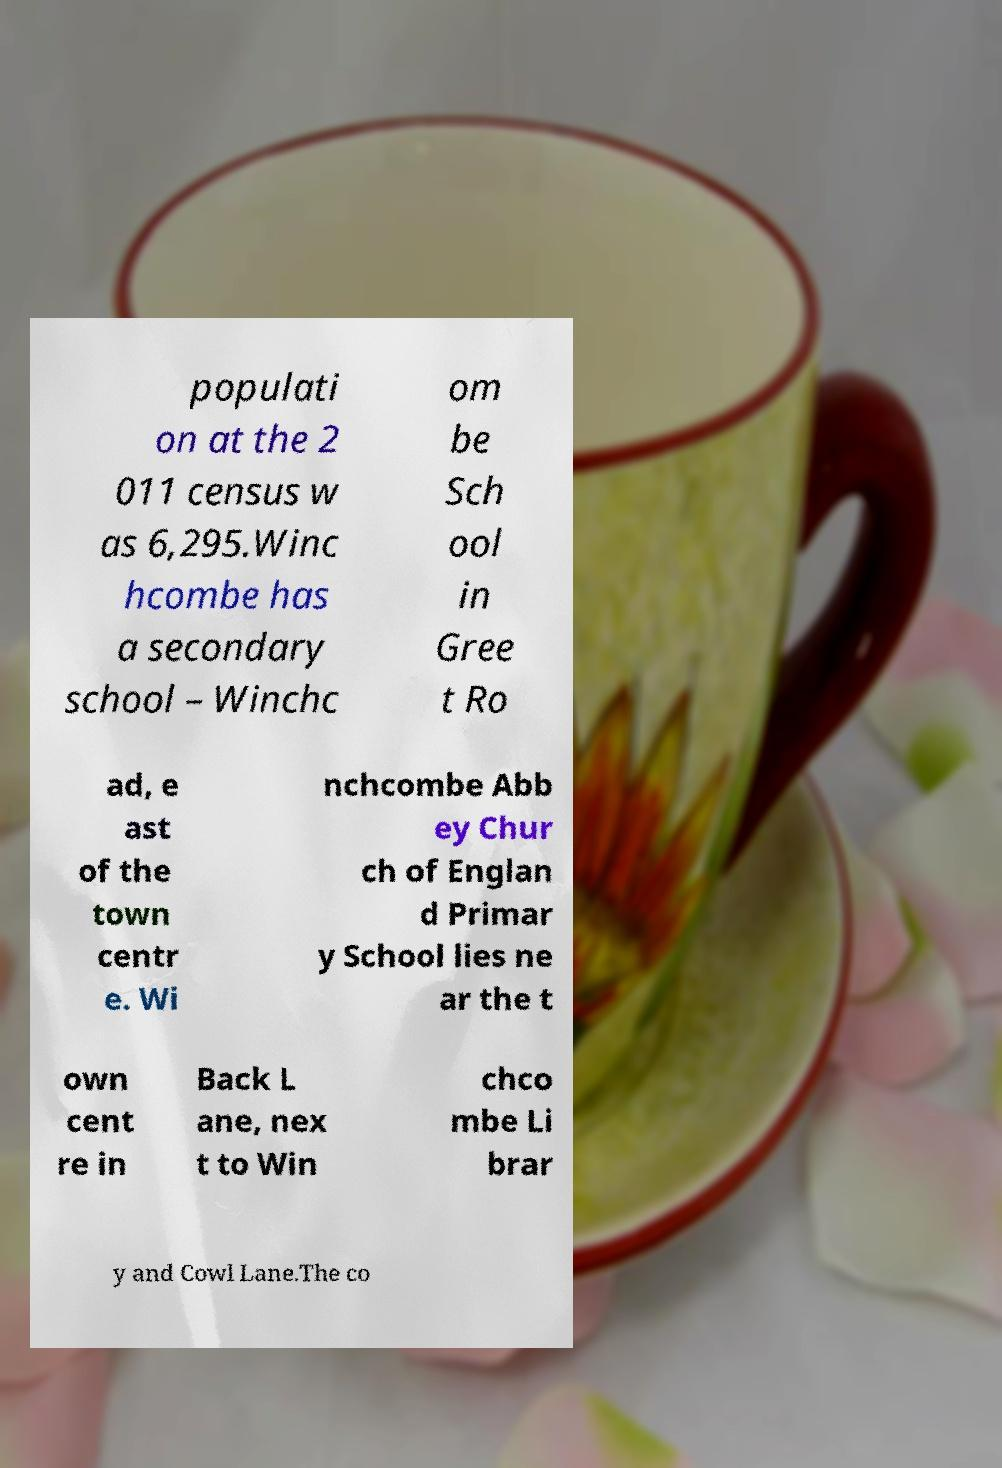Can you accurately transcribe the text from the provided image for me? populati on at the 2 011 census w as 6,295.Winc hcombe has a secondary school – Winchc om be Sch ool in Gree t Ro ad, e ast of the town centr e. Wi nchcombe Abb ey Chur ch of Englan d Primar y School lies ne ar the t own cent re in Back L ane, nex t to Win chco mbe Li brar y and Cowl Lane.The co 